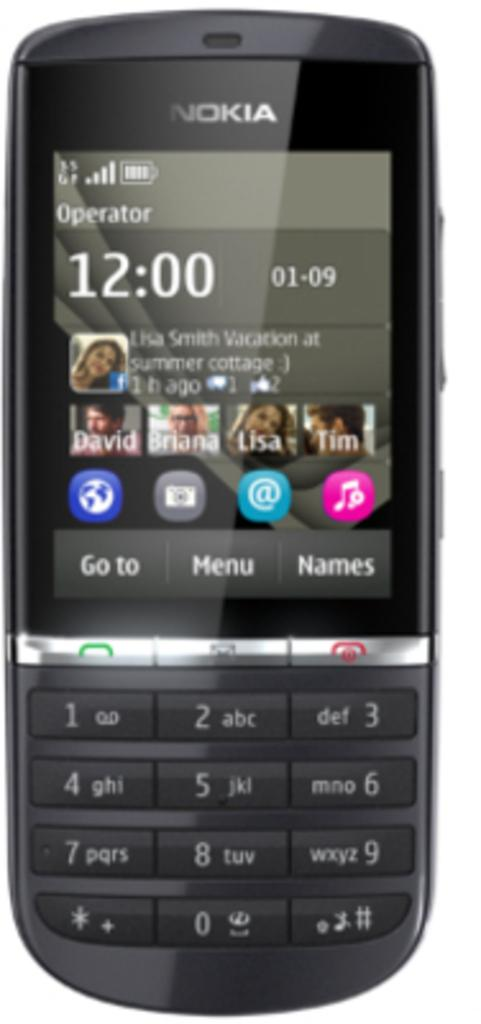<image>
Summarize the visual content of the image. A black Nokia cell phone with the time 12:00 shown on the screen. 